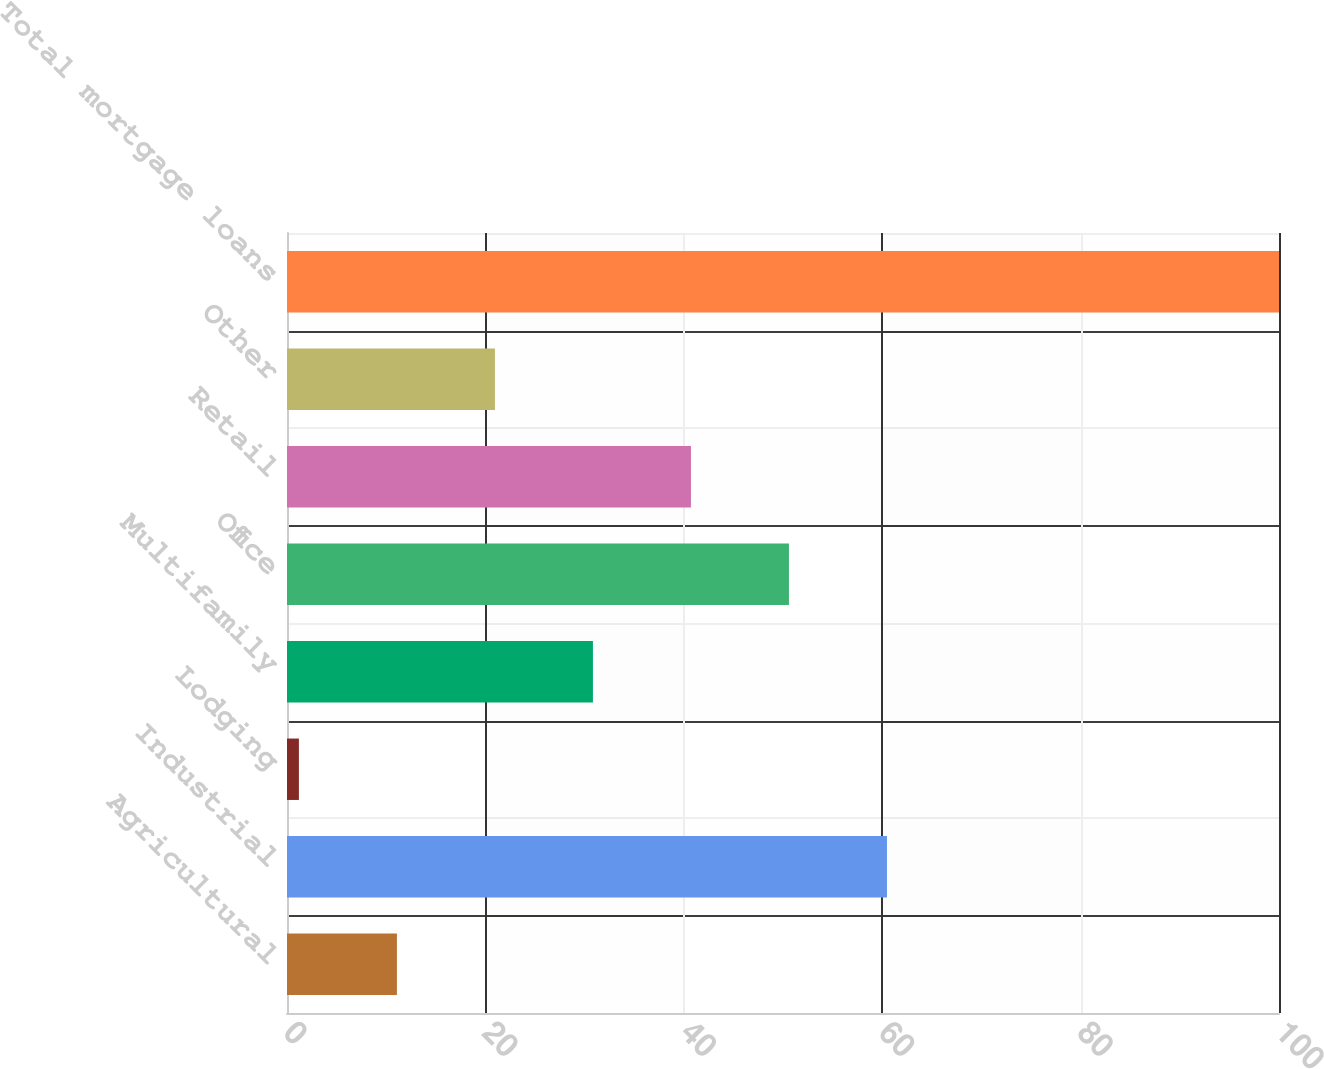Convert chart. <chart><loc_0><loc_0><loc_500><loc_500><bar_chart><fcel>Agricultural<fcel>Industrial<fcel>Lodging<fcel>Multifamily<fcel>Office<fcel>Retail<fcel>Other<fcel>Total mortgage loans<nl><fcel>11.08<fcel>60.48<fcel>1.2<fcel>30.84<fcel>50.6<fcel>40.72<fcel>20.96<fcel>100<nl></chart> 